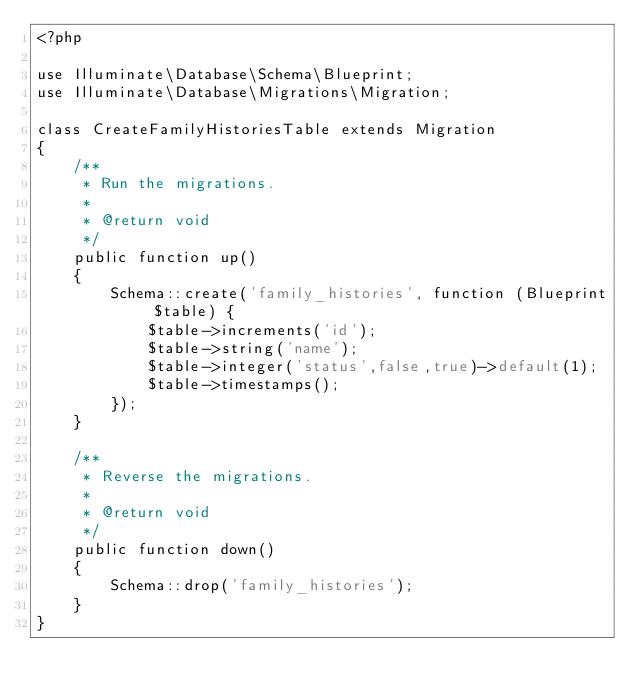<code> <loc_0><loc_0><loc_500><loc_500><_PHP_><?php

use Illuminate\Database\Schema\Blueprint;
use Illuminate\Database\Migrations\Migration;

class CreateFamilyHistoriesTable extends Migration
{
    /**
     * Run the migrations.
     *
     * @return void
     */
    public function up()
    {
        Schema::create('family_histories', function (Blueprint $table) {
            $table->increments('id');
            $table->string('name');
            $table->integer('status',false,true)->default(1);
            $table->timestamps();
        });
    }

    /**
     * Reverse the migrations.
     *
     * @return void
     */
    public function down()
    {
        Schema::drop('family_histories');
    }
}
</code> 